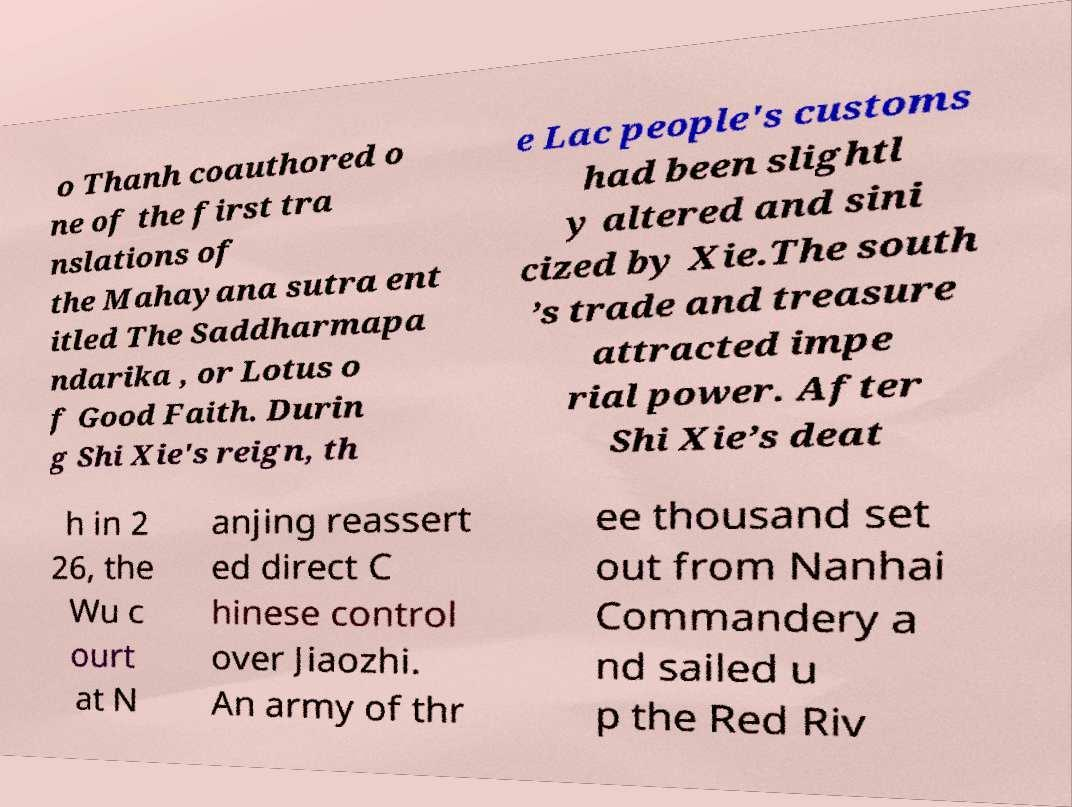Could you extract and type out the text from this image? o Thanh coauthored o ne of the first tra nslations of the Mahayana sutra ent itled The Saddharmapa ndarika , or Lotus o f Good Faith. Durin g Shi Xie's reign, th e Lac people's customs had been slightl y altered and sini cized by Xie.The south ’s trade and treasure attracted impe rial power. After Shi Xie’s deat h in 2 26, the Wu c ourt at N anjing reassert ed direct C hinese control over Jiaozhi. An army of thr ee thousand set out from Nanhai Commandery a nd sailed u p the Red Riv 